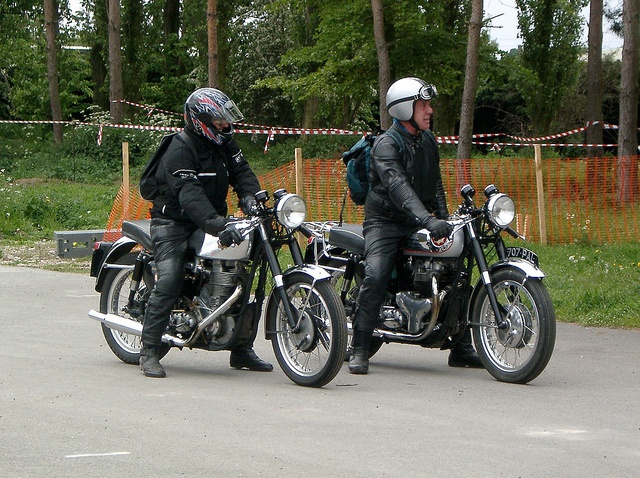Describe the objects in this image and their specific colors. I can see motorcycle in black, gray, darkgray, and white tones, motorcycle in black, gray, darkgray, and white tones, people in black, gray, purple, and darkgray tones, people in black, gray, white, and darkgray tones, and backpack in black, teal, gray, and darkblue tones in this image. 